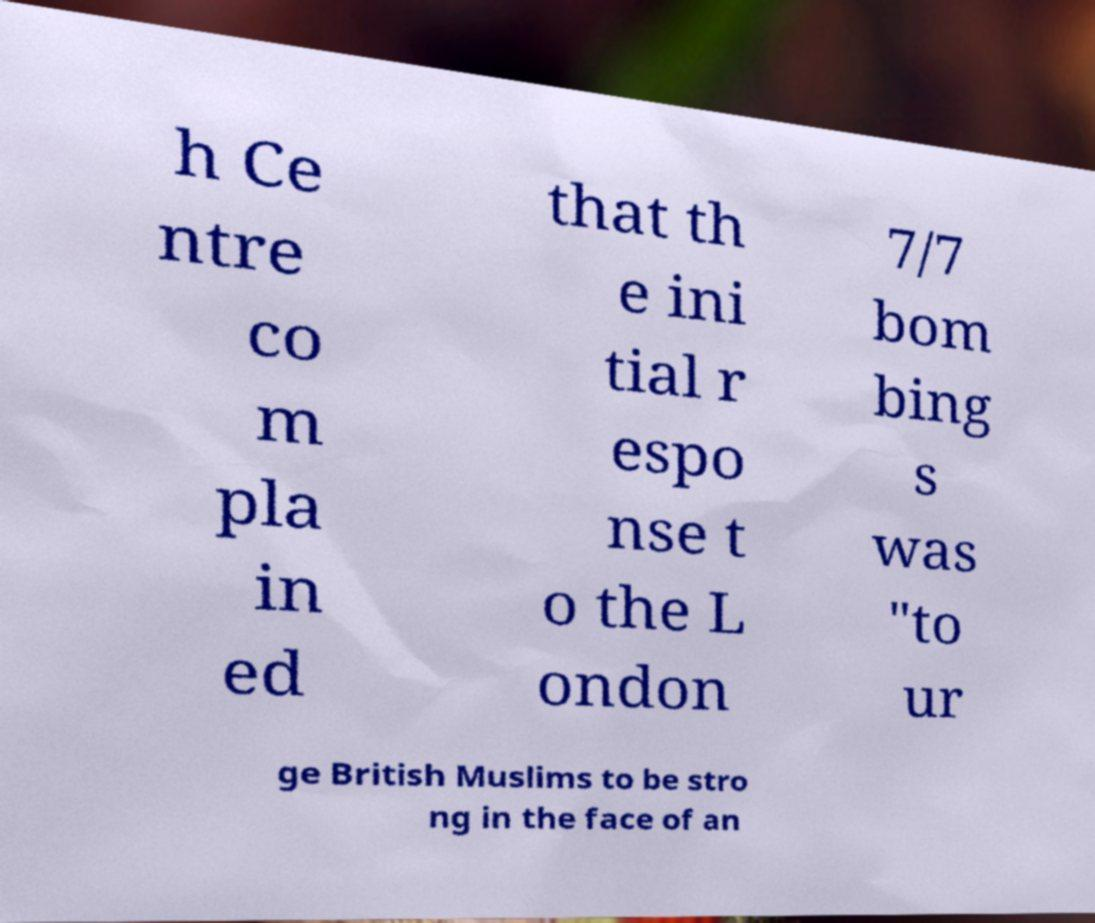There's text embedded in this image that I need extracted. Can you transcribe it verbatim? h Ce ntre co m pla in ed that th e ini tial r espo nse t o the L ondon 7/7 bom bing s was "to ur ge British Muslims to be stro ng in the face of an 